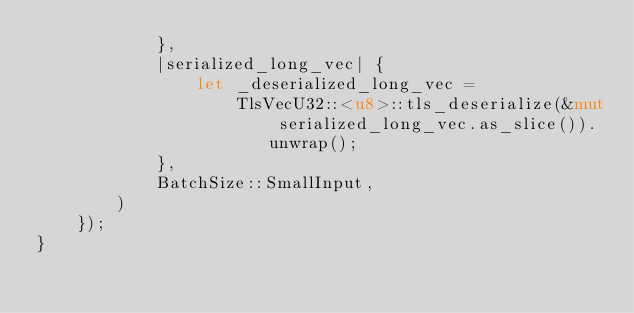<code> <loc_0><loc_0><loc_500><loc_500><_Rust_>            },
            |serialized_long_vec| {
                let _deserialized_long_vec =
                    TlsVecU32::<u8>::tls_deserialize(&mut serialized_long_vec.as_slice()).unwrap();
            },
            BatchSize::SmallInput,
        )
    });
}
</code> 